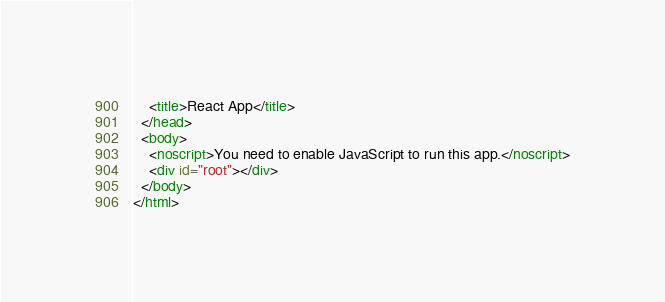Convert code to text. <code><loc_0><loc_0><loc_500><loc_500><_HTML_>
    <title>React App</title>
  </head>
  <body>
    <noscript>You need to enable JavaScript to run this app.</noscript>
    <div id="root"></div>
  </body>
</html>
</code> 